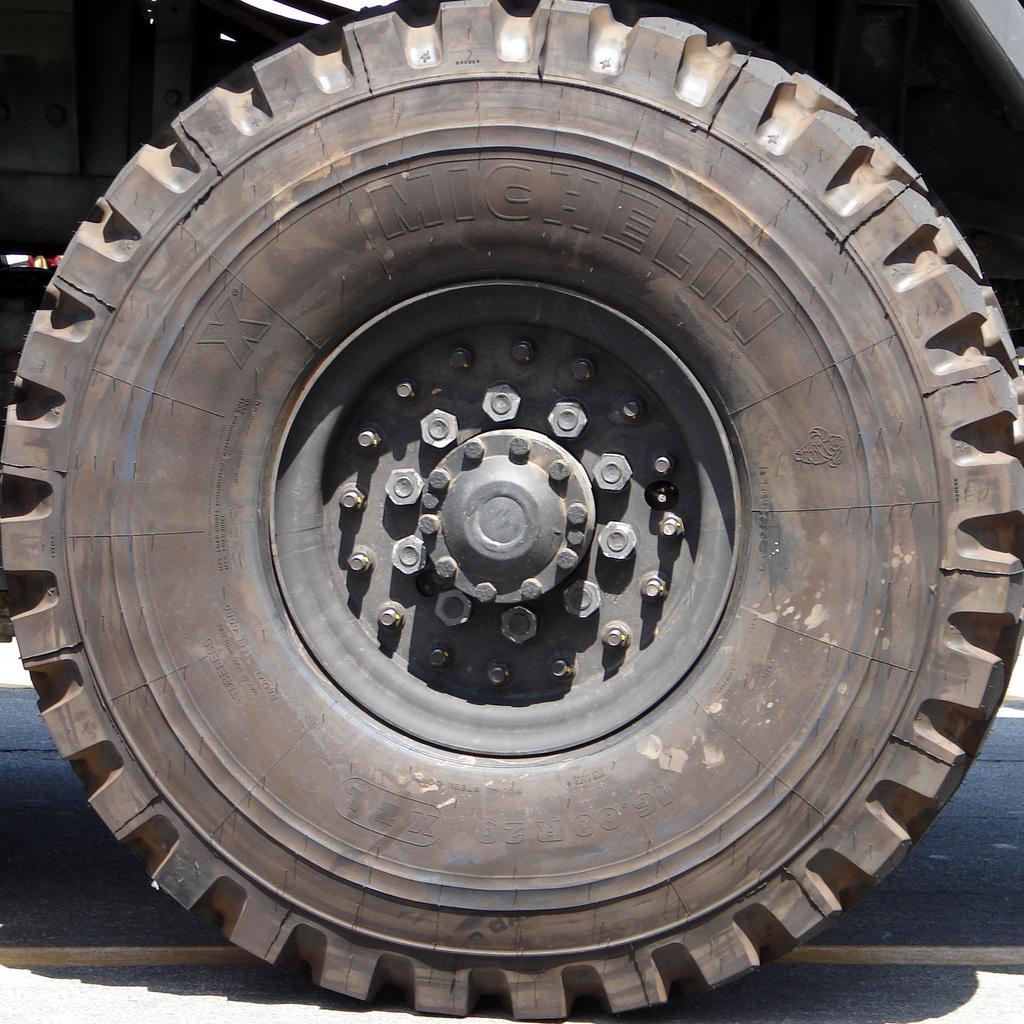Could you give a brief overview of what you see in this image? In this image we can see tire and shadow on the road. 